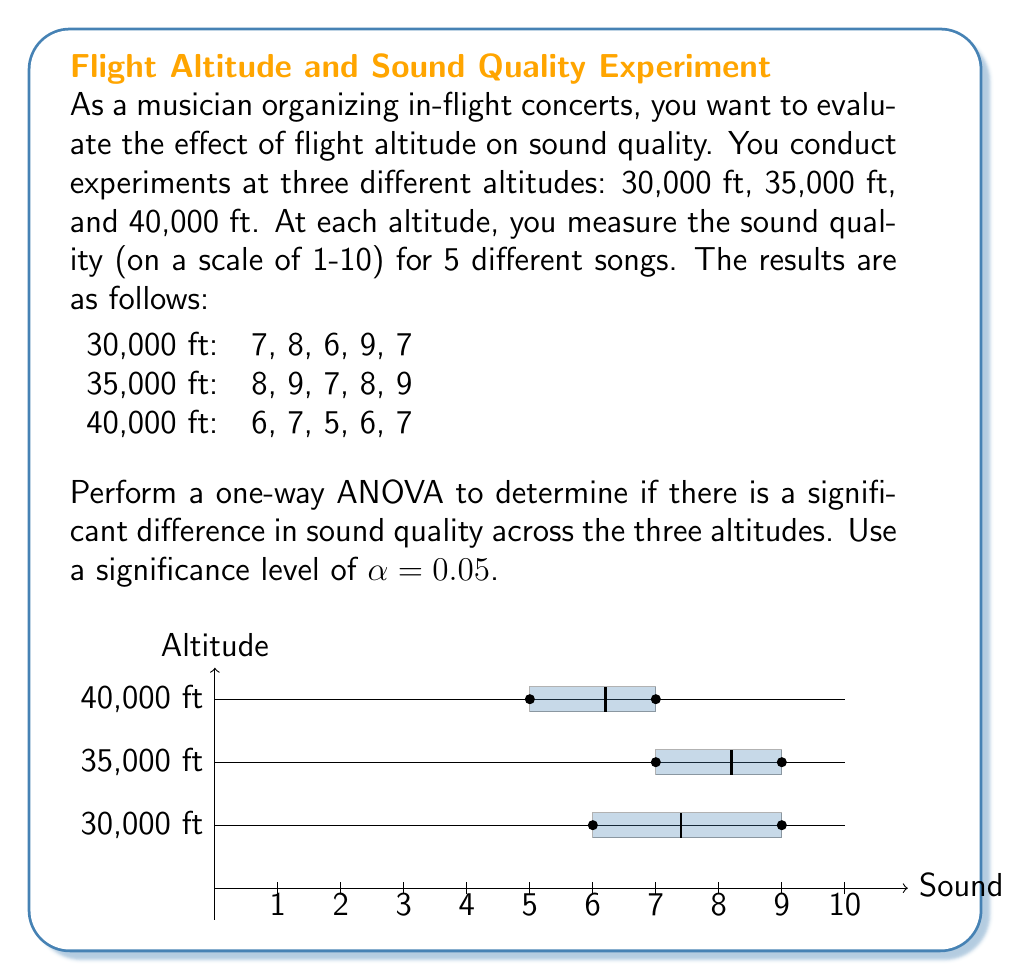Solve this math problem. To perform a one-way ANOVA, we'll follow these steps:

1. Calculate the sum of squares between groups (SSB)
2. Calculate the sum of squares within groups (SSW)
3. Calculate the total sum of squares (SST)
4. Calculate degrees of freedom
5. Calculate mean squares
6. Calculate F-statistic
7. Compare F-statistic to critical F-value

Step 1: Calculate SSB
First, we need to find the grand mean and group means:

Grand mean: $\bar{X} = \frac{(7+8+6+9+7)+(8+9+7+8+9)+(6+7+5+6+7)}{15} = 7.27$

Group means:
$\bar{X}_1 = 7.4$ (30,000 ft)
$\bar{X}_2 = 8.2$ (35,000 ft)
$\bar{X}_3 = 6.2$ (40,000 ft)

SSB = $n\sum_{i=1}^k(\bar{X}_i - \bar{X})^2$
    = $5[(7.4-7.27)^2 + (8.2-7.27)^2 + (6.2-7.27)^2]$
    = $5(0.0169 + 0.8649 + 1.1449)$
    = $10.1335$

Step 2: Calculate SSW
SSW = $\sum_{i=1}^k\sum_{j=1}^n(X_{ij} - \bar{X}_i)^2$
    = $[(7-7.4)^2 + (8-7.4)^2 + (6-7.4)^2 + (9-7.4)^2 + (7-7.4)^2]$
    + $[(8-8.2)^2 + (9-8.2)^2 + (7-8.2)^2 + (8-8.2)^2 + (9-8.2)^2]$
    + $[(6-6.2)^2 + (7-6.2)^2 + (5-6.2)^2 + (6-6.2)^2 + (7-6.2)^2]$
    = $5.2 + 2.8 + 3.2$
    = $11.2$

Step 3: Calculate SST
SST = SSB + SSW = $10.1335 + 11.2 = 21.3335$

Step 4: Calculate degrees of freedom
df between groups (dfB) = k - 1 = 3 - 1 = 2
df within groups (dfW) = N - k = 15 - 3 = 12
df total (dfT) = N - 1 = 15 - 1 = 14

Step 5: Calculate mean squares
MSB = SSB / dfB = $10.1335 / 2 = 5.06675$
MSW = SSW / dfW = $11.2 / 12 = 0.93333$

Step 6: Calculate F-statistic
F = MSB / MSW = $5.06675 / 0.93333 = 5.4286$

Step 7: Compare F-statistic to critical F-value
For α = 0.05, dfB = 2, and dfW = 12, the critical F-value is approximately 3.89.

Since our calculated F-statistic (5.4286) is greater than the critical F-value (3.89), we reject the null hypothesis.
Answer: F(2,12) = 5.4286, p < 0.05. Significant difference in sound quality across altitudes. 